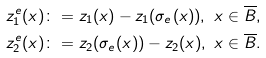Convert formula to latex. <formula><loc_0><loc_0><loc_500><loc_500>z _ { 1 } ^ { e } ( x ) & \colon = z _ { 1 } ( x ) - z _ { 1 } ( \sigma _ { e } ( x ) ) , \ x \in \overline { B } , \\ z _ { 2 } ^ { e } ( x ) & \colon = z _ { 2 } ( \sigma _ { e } ( x ) ) - z _ { 2 } ( x ) , \ x \in \overline { B } .</formula> 